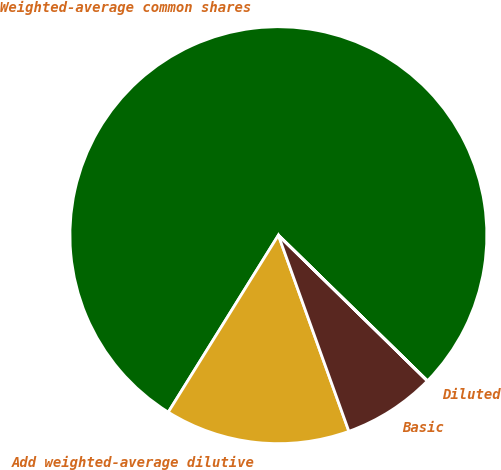Convert chart to OTSL. <chart><loc_0><loc_0><loc_500><loc_500><pie_chart><fcel>Weighted-average common shares<fcel>Add weighted-average dilutive<fcel>Basic<fcel>Diluted<nl><fcel>78.45%<fcel>14.35%<fcel>7.18%<fcel>0.01%<nl></chart> 